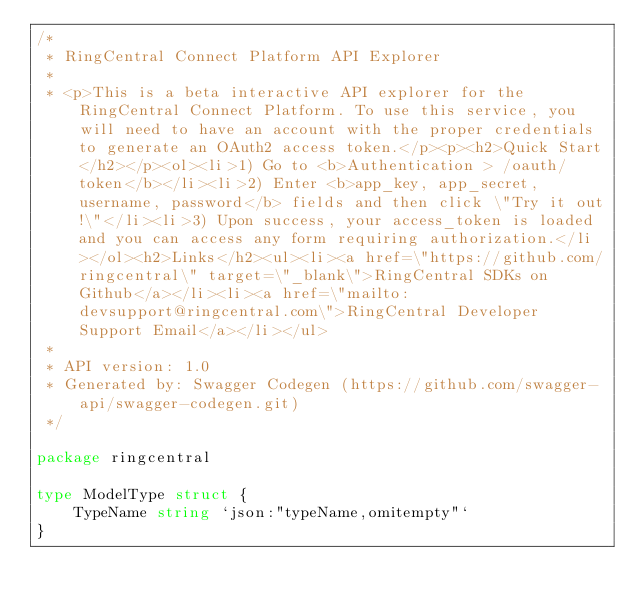Convert code to text. <code><loc_0><loc_0><loc_500><loc_500><_Go_>/*
 * RingCentral Connect Platform API Explorer
 *
 * <p>This is a beta interactive API explorer for the RingCentral Connect Platform. To use this service, you will need to have an account with the proper credentials to generate an OAuth2 access token.</p><p><h2>Quick Start</h2></p><ol><li>1) Go to <b>Authentication > /oauth/token</b></li><li>2) Enter <b>app_key, app_secret, username, password</b> fields and then click \"Try it out!\"</li><li>3) Upon success, your access_token is loaded and you can access any form requiring authorization.</li></ol><h2>Links</h2><ul><li><a href=\"https://github.com/ringcentral\" target=\"_blank\">RingCentral SDKs on Github</a></li><li><a href=\"mailto:devsupport@ringcentral.com\">RingCentral Developer Support Email</a></li></ul>
 *
 * API version: 1.0
 * Generated by: Swagger Codegen (https://github.com/swagger-api/swagger-codegen.git)
 */

package ringcentral

type ModelType struct {
	TypeName string `json:"typeName,omitempty"`
}
</code> 